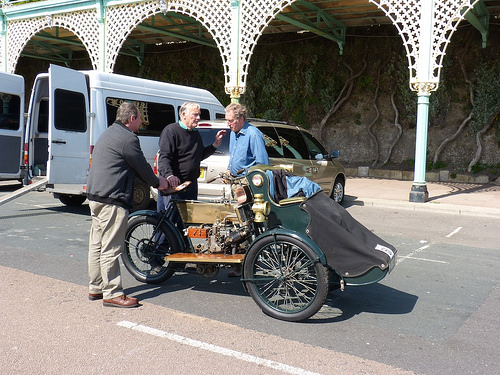<image>
Is there a man to the left of the man? Yes. From this viewpoint, the man is positioned to the left side relative to the man. Is there a man in the van? No. The man is not contained within the van. These objects have a different spatial relationship. 